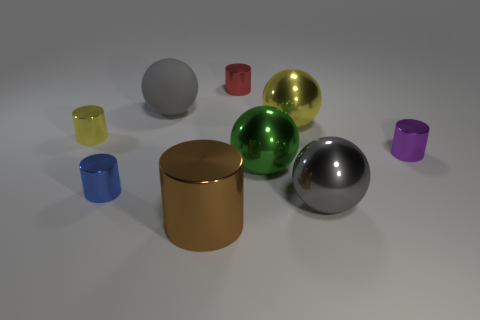Is the number of small cylinders that are to the right of the small red shiny object greater than the number of large gray rubber cubes? The number of small cylinders to the right of the small red shiny object is greater than the number of large gray rubber cubes. Specifically, there are two small cylinders on that side, while only one large gray rubber cube is present in the scene. 